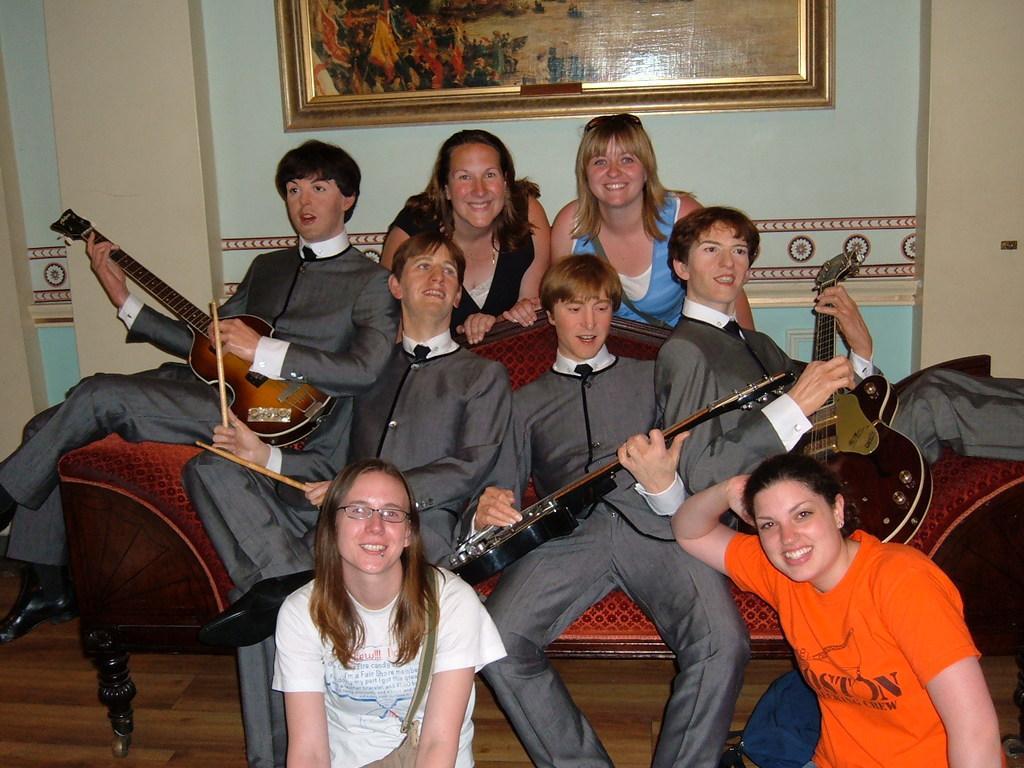Can you describe this image briefly? In this picture there are so many people sitting on the table and playing guitar also two women are sitting on the floor. In the background there is a painting attached to the wall. 